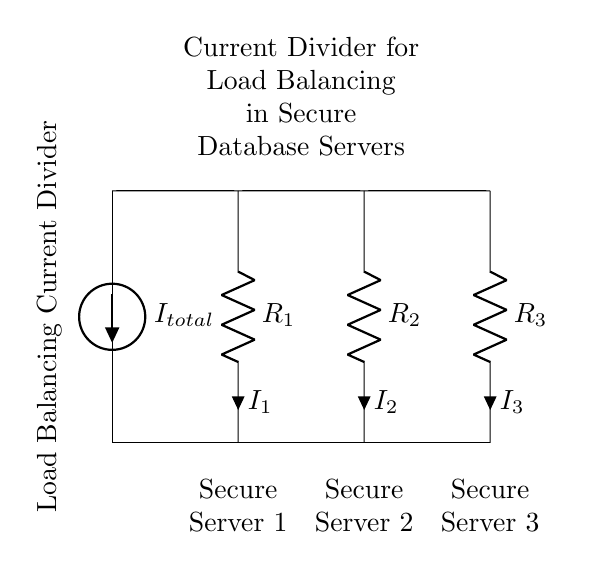What is the total current entering the circuit? The total current is represented by the label for the current source at the top, denoted as \(I_{total}\).
Answer: I total What are the resistance values in the circuit? The resistances \(R_1\), \(R_2\), and \(R_3\) are placed in parallel, and each is labeled individually on the circuit diagram. The exact resistance values are not provided, but they are indicated by their respective labels.
Answer: R one, R two, R three How many secure servers are connected in this circuit? The circuit shows three distinct loads, each labeled as a secure server at the bottom, indicating that there are three secure servers connected to the current divider.
Answer: Three What is the relationship between the currents \(I_1\), \(I_2\), and \(I_3\)? In a current divider, the total current flowing into the circuit is equal to the sum of the currents through each resistor. Therefore, the relationship can be expressed as \(I_{total} = I_1 + I_2 + I_3\).
Answer: I total equals I one plus I two plus I three Which component likely ensures load balancing in this circuit? The arrangement of three resistors in parallel constitutes the current divider, which is key for achieving load balancing among the secure servers by sharing the total current.
Answer: Resistors 